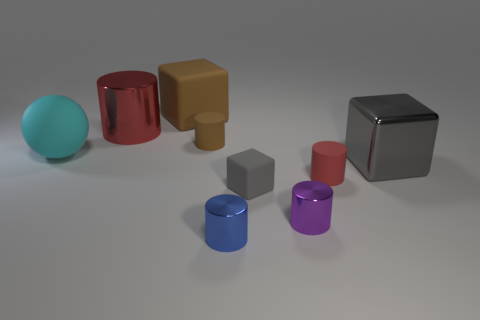The matte thing that is the same color as the big metal cylinder is what shape?
Offer a terse response. Cylinder. Is the number of brown matte blocks on the right side of the red shiny object greater than the number of large gray metal cylinders?
Offer a terse response. Yes. How many gray blocks have the same size as the cyan rubber thing?
Provide a succinct answer. 1. What size is the matte block that is the same color as the big metallic cube?
Ensure brevity in your answer.  Small. What number of things are either cyan balls or big metallic things that are on the right side of the big brown block?
Your response must be concise. 2. There is a tiny cylinder that is both left of the small gray object and in front of the tiny block; what color is it?
Give a very brief answer. Blue. Is the blue metal object the same size as the cyan rubber object?
Provide a short and direct response. No. There is a cylinder that is behind the brown rubber cylinder; what color is it?
Provide a succinct answer. Red. Are there any other large rubber spheres of the same color as the ball?
Ensure brevity in your answer.  No. What is the color of the block that is the same size as the purple cylinder?
Make the answer very short. Gray. 